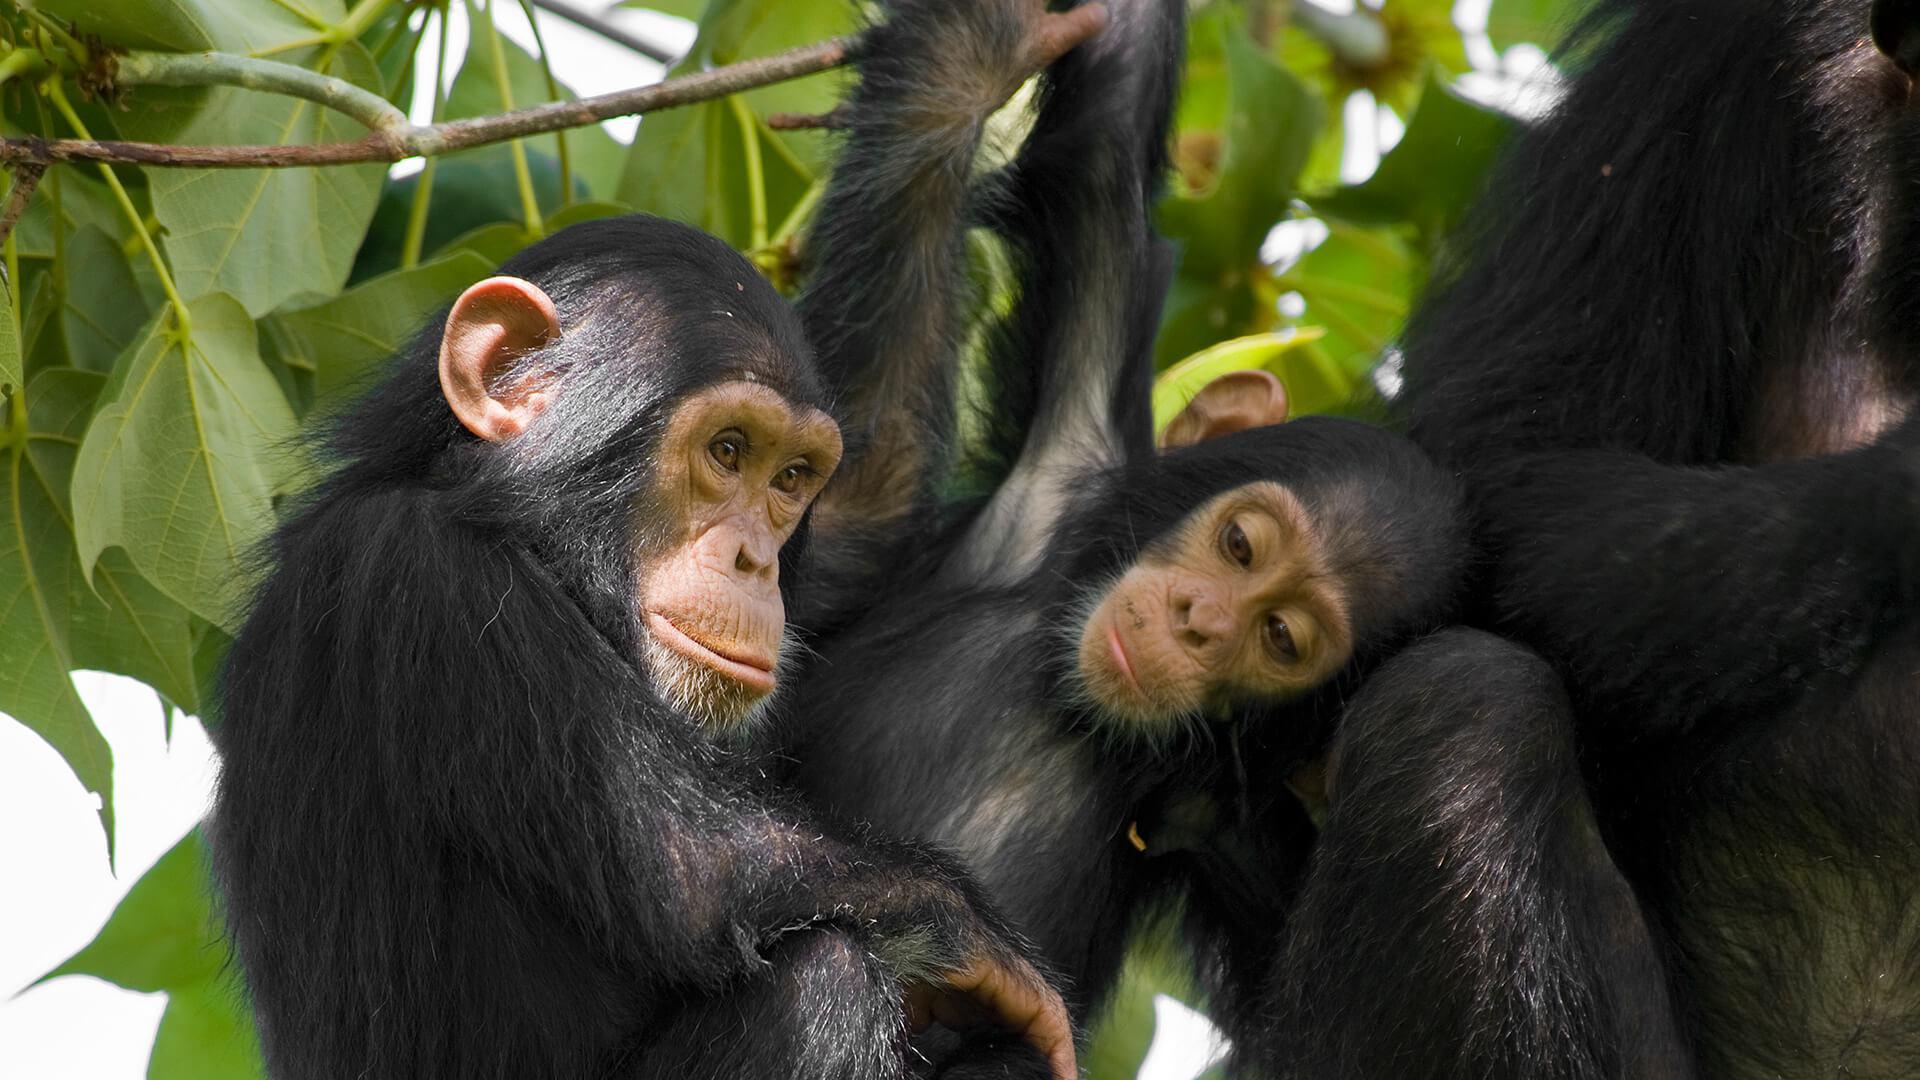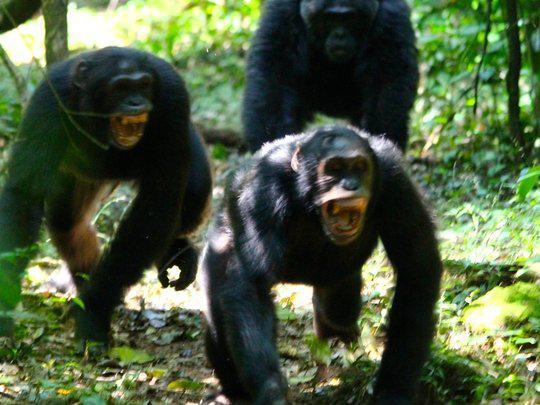The first image is the image on the left, the second image is the image on the right. Assess this claim about the two images: "Atleast one image shows exactly two chimps sitting in the grass.". Correct or not? Answer yes or no. No. The first image is the image on the left, the second image is the image on the right. Analyze the images presented: Is the assertion "The image on the left shows a baby monkey clinging on its mother." valid? Answer yes or no. No. 